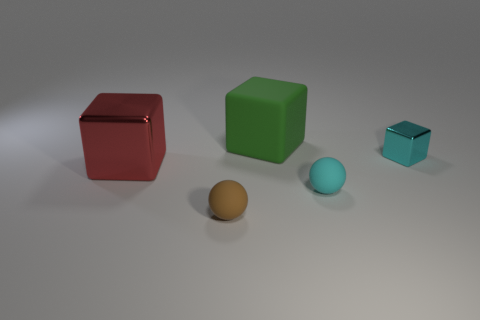Add 1 big blue metallic blocks. How many objects exist? 6 Subtract all cubes. How many objects are left? 2 Subtract 0 blue cubes. How many objects are left? 5 Subtract all red objects. Subtract all tiny shiny objects. How many objects are left? 3 Add 1 green matte blocks. How many green matte blocks are left? 2 Add 5 large metallic things. How many large metallic things exist? 6 